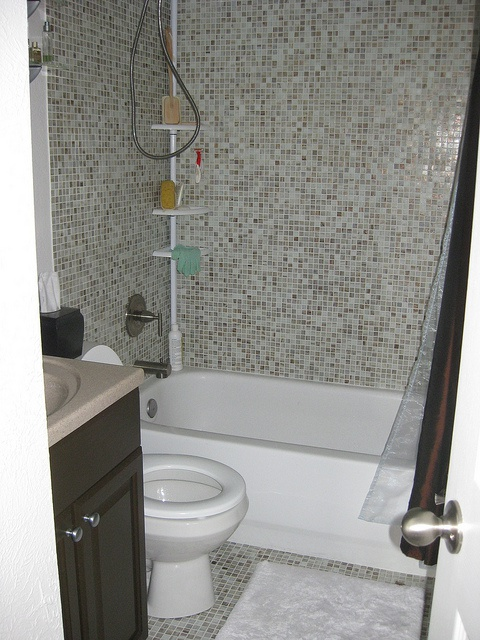Describe the objects in this image and their specific colors. I can see toilet in lightgray, darkgray, and gray tones and sink in lightgray and gray tones in this image. 